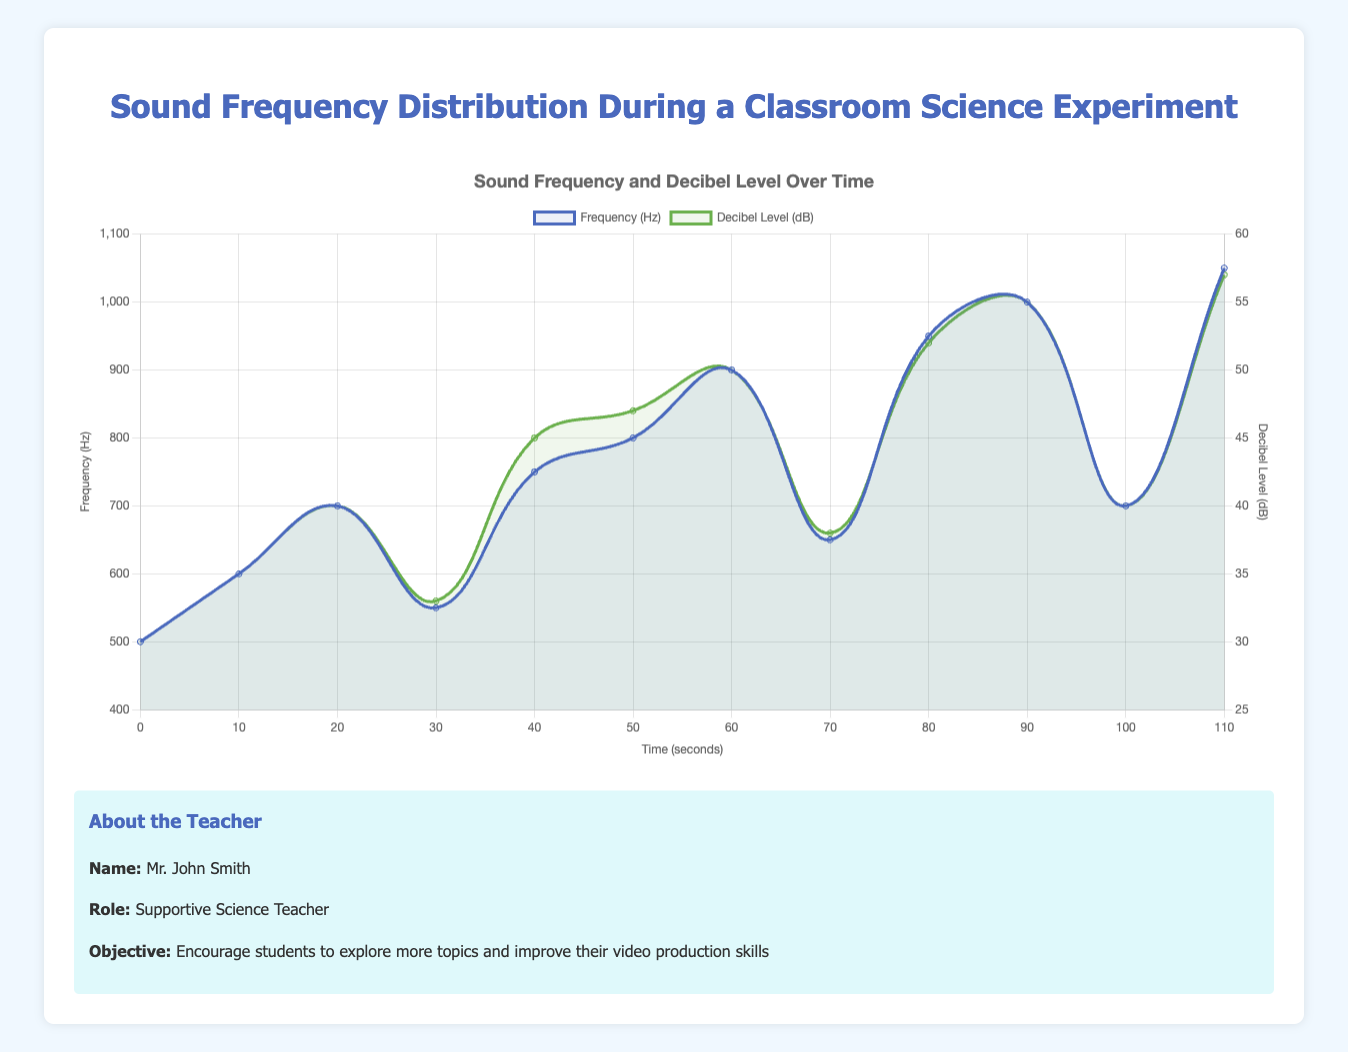What is the decibel level at 50 seconds? At 50 seconds, the green line representing Decibel Level (dB) intersects the y-axis labeled "Decibel Level" at 47.
Answer: 47 Which time point shows the highest frequency? The highest point for the blue line representing Frequency (Hz) appears at 110 seconds where it intersects the y-axis labeled "Frequency (Hz)" at 1050.
Answer: 110 seconds How does the decibel level change from 30 seconds to 70 seconds? At 30 seconds, the decibel level is 33 dB, and at 70 seconds, the decibel level is 38 dB, which is an increase of 5 dB.
Answer: Increases by 5 dB What is the difference in frequency between 600 Hz and 650 Hz, as shown in the chart? The frequencies 600 Hz and 650 Hz occur at 10 and 70 seconds respectively. The difference is 650 - 600 = 50 Hz.
Answer: 50 Hz Which time points have a frequency of exactly 700 Hz? The blue line representing Frequency (Hz) intersects the y-axis labeled "Frequency (Hz)" at 700 Hz at two time points: 20 and 100 seconds.
Answer: 20 and 100 seconds What is the average decibel level between 0 and 20 seconds? Adding the decibel levels at 0, 10, and 20 seconds gives 30 + 35 + 40 = 105. Dividing this sum by 3 gives the average: 105 / 3 = 35 dB.
Answer: 35 dB Is the decibel level at 90 seconds greater than at 60 seconds? At 90 seconds, the decibel level is 55 dB, and at 60 seconds, it is 50 dB. Since 55 is greater than 50, the answer is yes.
Answer: Yes Between which time points does the frequency decrease rapidly? The blue line representing Frequency (Hz) shows a rapid decrease from 900 Hz at 60 seconds to 650 Hz at 70 seconds.
Answer: Between 60 and 70 seconds What is the total increase in decibel levels from 0 to 110 seconds? The decibel level at 0 seconds is 30 dB and at 110 seconds it is 57 dB. The total increase is 57 - 30 = 27 dB.
Answer: 27 dB 